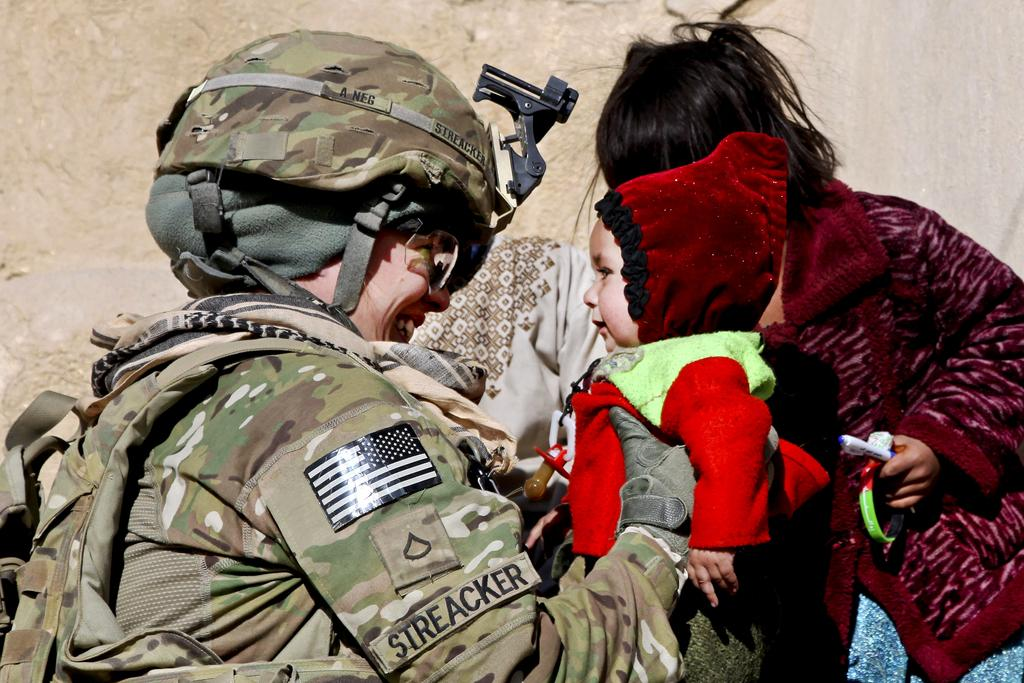Who is present in the image? There are children and a person in uniform in the image. What is the person in uniform doing? The person in uniform is holding a baby. What else can be seen in the image? There is text visible in the image. What type of comb is being used by the person in the image? There is no comb present in the image. Where is the market located in the image? There is no market present in the image. 